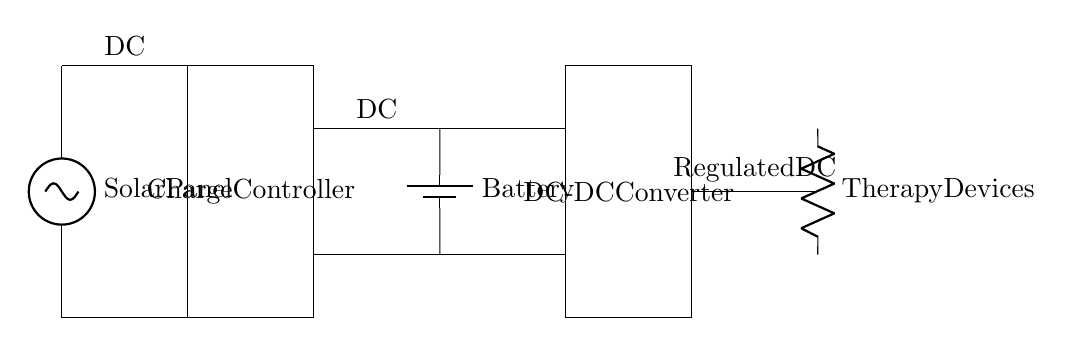What component supplies energy to the system? The energy for the system is supplied by the solar panel, which is shown at the beginning of the circuit diagram.
Answer: Solar panel What does the charge controller do? The charge controller is responsible for managing the flow of energy from the solar panel to the battery to prevent overcharging, helping to ensure the battery operates efficiently.
Answer: Charge controller How many main components are in the circuit? The circuit consists of four main components: the solar panel, charge controller, battery, and DC-DC converter. Counting these provides the total number of distinct functional elements.
Answer: Four What is the purpose of the DC-DC converter in the circuit? The DC-DC converter converts the voltage from the battery to a regulated level needed for the therapy devices, ensuring they receive the appropriate power for operation.
Answer: Voltage regulation What type of devices are powered by this system? The system powers therapy devices, which are specifically indicated in the diagram as the output connected to the last stage of the circuit.
Answer: Therapy devices What is the output voltage type for the therapy devices? The output voltage type is regulated DC, indicating that the power supplied to the therapy devices is stable and suitable for their use.
Answer: Regulated DC 